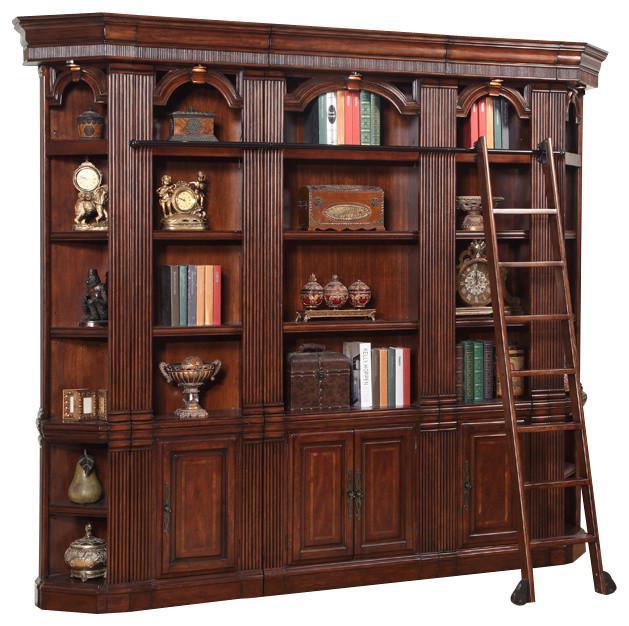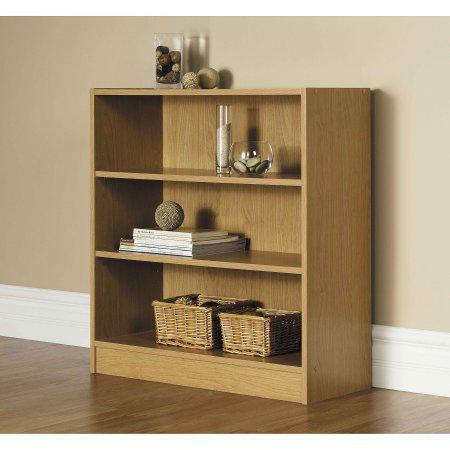The first image is the image on the left, the second image is the image on the right. Given the left and right images, does the statement "An image of a brown bookshelf includes a ladder design of some type." hold true? Answer yes or no. Yes. The first image is the image on the left, the second image is the image on the right. Evaluate the accuracy of this statement regarding the images: "There is a window visible in one of the photos.". Is it true? Answer yes or no. No. 